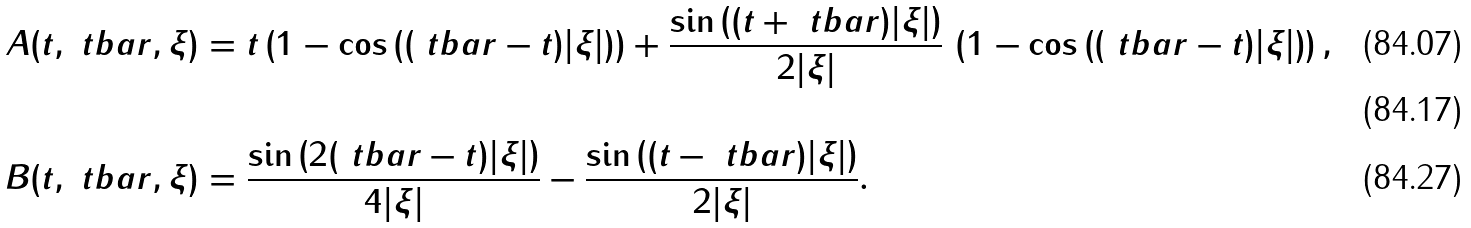<formula> <loc_0><loc_0><loc_500><loc_500>A ( t , \ t b a r , \xi ) & = t \left ( 1 - \cos \left ( ( \ t b a r - t ) | \xi | \right ) \right ) + \frac { \sin \left ( ( t + \ t b a r ) | \xi | \right ) } { 2 | \xi | } \, \left ( 1 - \cos \left ( ( \ t b a r - t ) | \xi | \right ) \right ) , \\ \\ B ( t , \ t b a r , \xi ) & = \frac { \sin \left ( 2 ( \ t b a r - t ) | \xi | \right ) } { 4 | \xi | } - \frac { \sin \left ( ( t - \ t b a r ) | \xi | \right ) } { 2 | \xi | } .</formula> 